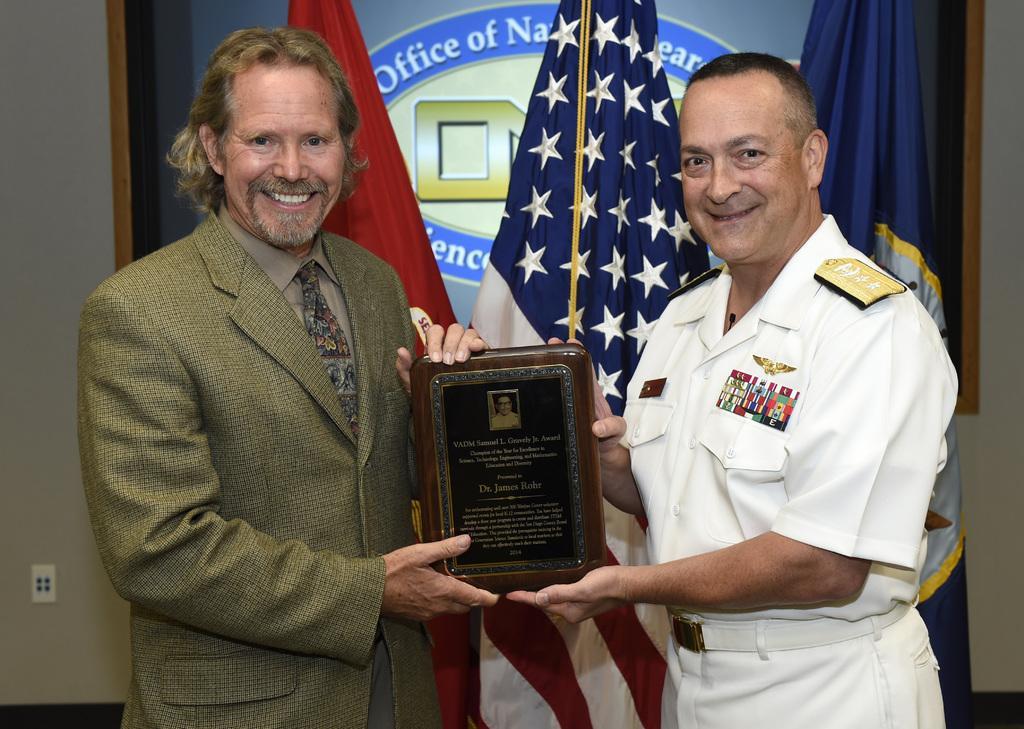Describe this image in one or two sentences. In this image there are two men standing towards the bottom of the image, they are holding an object, there are flags behind the men, there is a board towards the top of the image, there is text on the board, at the background of the image there is a wall. 